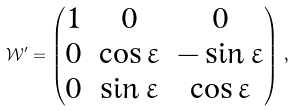<formula> <loc_0><loc_0><loc_500><loc_500>\mathcal { W } ^ { \prime } = \begin{pmatrix} 1 & 0 & 0 \\ 0 & \cos \varepsilon & - \sin \varepsilon \\ 0 & \sin \varepsilon & \cos \varepsilon \end{pmatrix} \, ,</formula> 